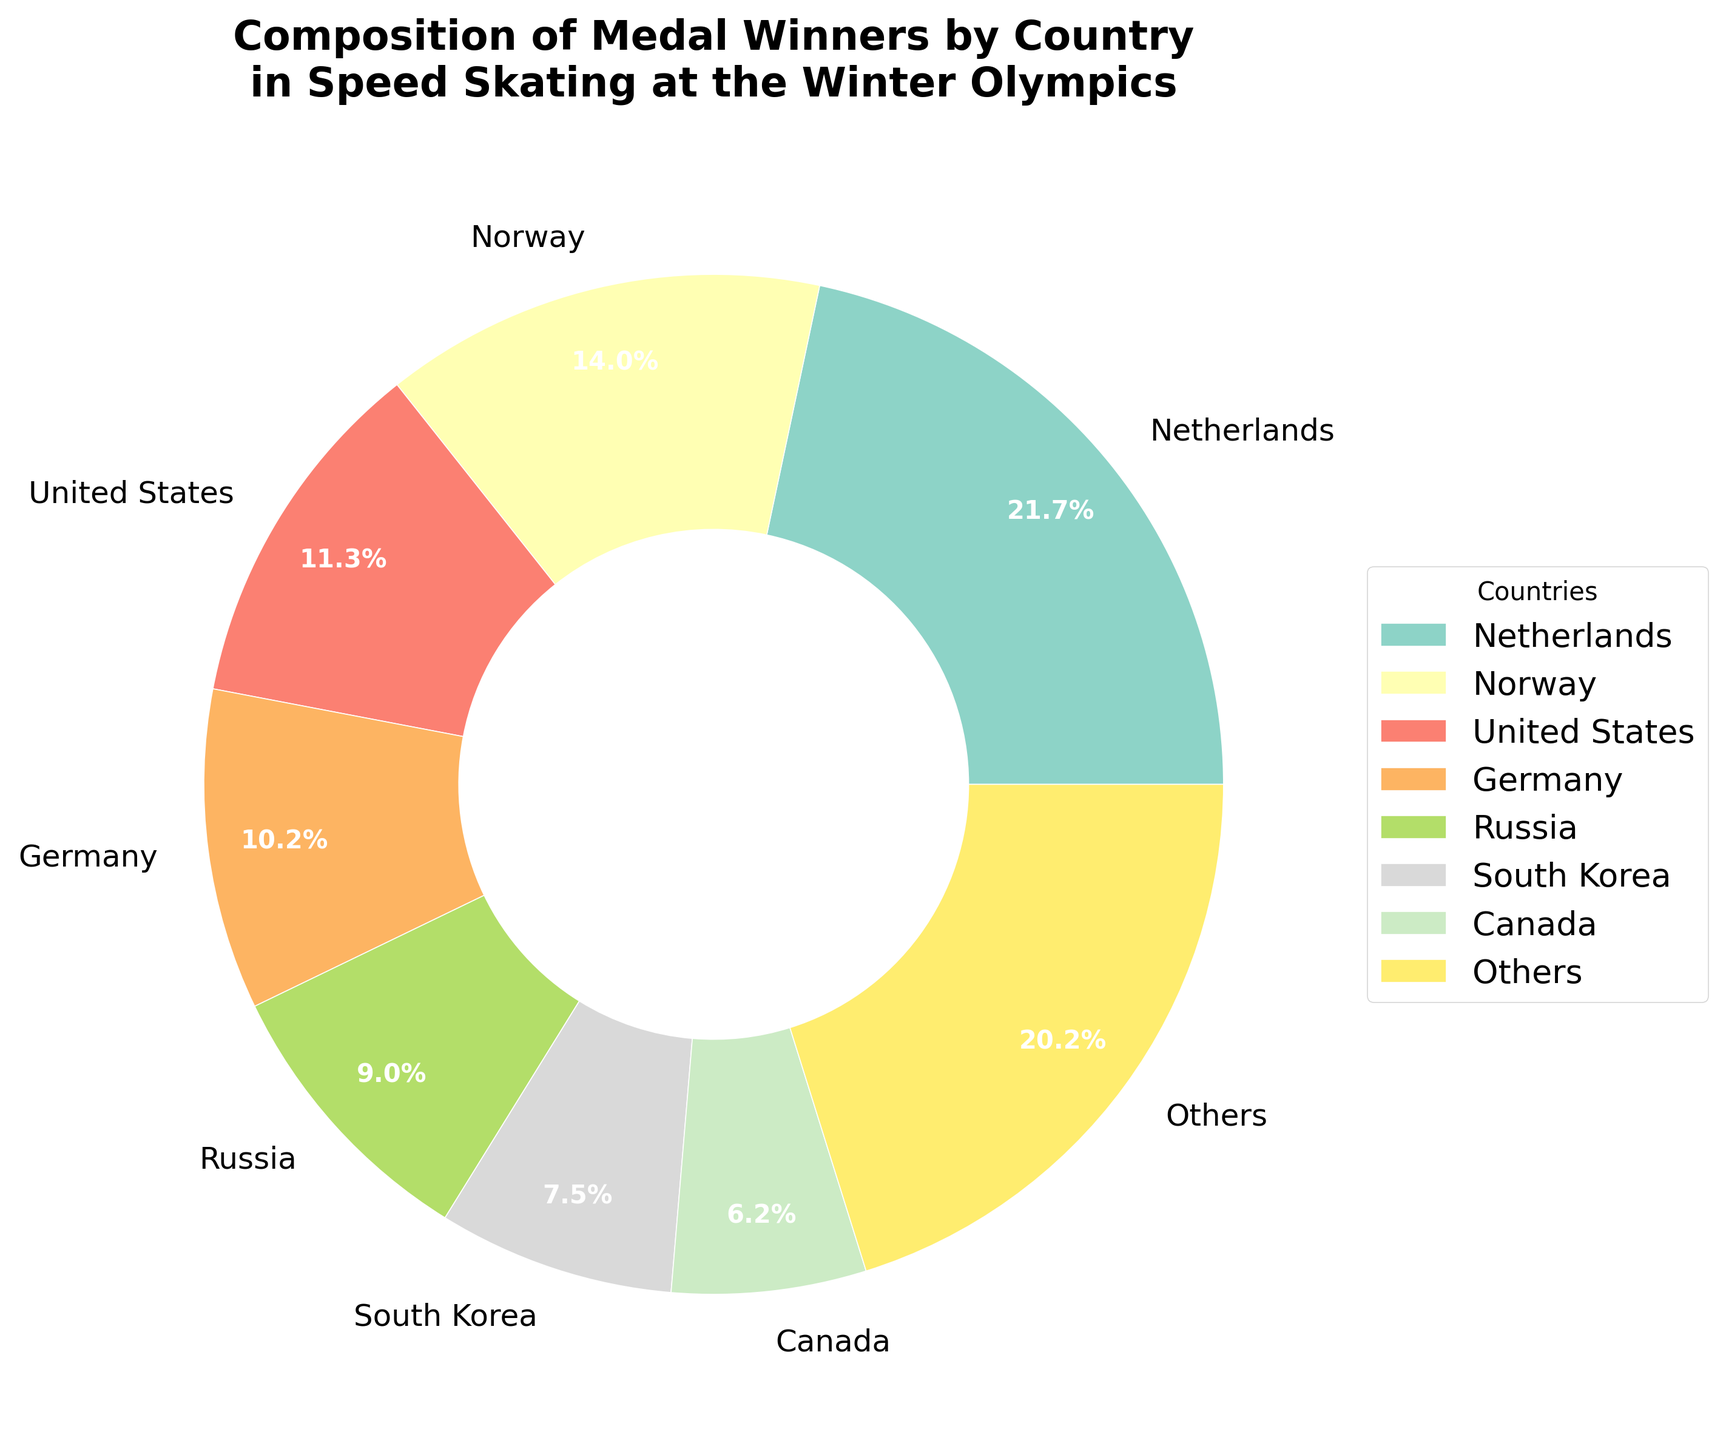Which country has won the most medals in speed skating at the Winter Olympics? By observing the pie chart, the segment representing the Netherlands is the largest, indicating that they have won the most medals in speed skating.
Answer: Netherlands Which two countries combined have won fewer medals than the Netherlands? The Netherlands has the largest segment. Norway and the United States combined (84 + 68 = 152) have more than the Netherlands. However, Germany and Russia combined (61 + 54 = 115) have fewer than the Netherlands.
Answer: Germany and Russia What percentage of total medals are won by countries other than the top few listed? The chart indicates that countries listed as "Others" constitute one of the segments. Observing the size of this segment gives the percentage of medals won by these other countries.
Answer: Percentage from the "Others" segment Which country ranks third in terms of the number of medals won? The third largest segment represents the United States, following the Netherlands and Norway.
Answer: United States Is the number of medals won by China more, less, or equal to that won by Austria? Observing the pie chart, the segment representing China is smaller than the one for Austria, indicating China has fewer medals.
Answer: Less What is the total number of medals won by the three least successful countries listed? The least successful countries shown are China, Switzerland, and Belgium. Summing their medals (8 + 6 + 5), we find the total.
Answer: 19 Comparing Russia and Canada, which country has won more medals? By comparing the sizes of the segments for Russia and Canada, the one for Russia is larger, indicating that Russia has won more medals.
Answer: Russia Which country has won nearly double the number of medals as South Korea according to the pie chart? South Korea has 45 medals. By doubling this (45 x 2 = 90), we look for a country close to this value. Norway, with 84, is the closest.
Answer: Norway Do Norway, the United States, and Germany together account for more than 50% of the total medals? By summing their medals (84 + 68 + 61 = 213) and comparing it to the total (474), we notice that 213 is approximately 44.9%, which is less than 50%.
Answer: No 